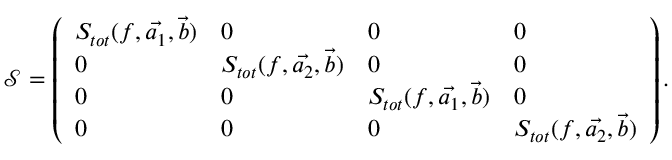Convert formula to latex. <formula><loc_0><loc_0><loc_500><loc_500>\mathcal { S } = \left ( \begin{array} { l l l l } { S _ { t o t } ( f , \vec { a _ { 1 } } , \vec { b } ) } & { 0 } & { 0 } & { 0 } \\ { 0 } & { S _ { t o t } ( f , \vec { a _ { 2 } } , \vec { b } ) } & { 0 } & { 0 } \\ { 0 } & { 0 } & { S _ { t o t } ( f , \vec { a _ { 1 } } , \vec { b } ) } & { 0 } \\ { 0 } & { 0 } & { 0 } & { S _ { t o t } ( f , \vec { a _ { 2 } } , \vec { b } ) } \end{array} \right ) .</formula> 